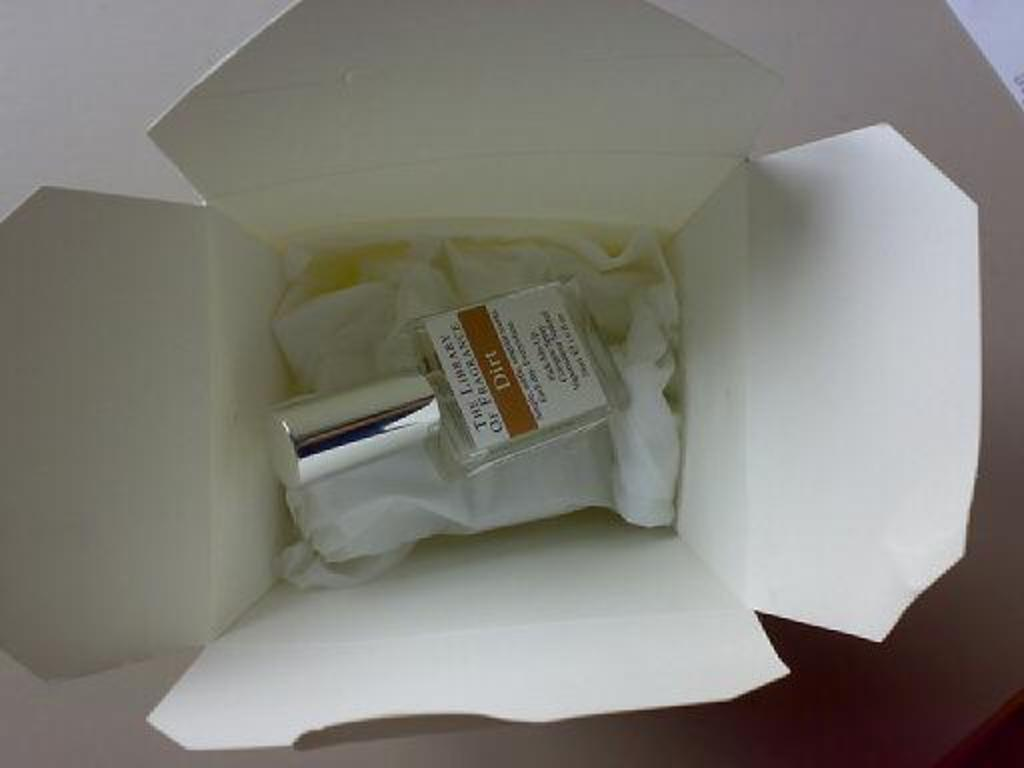What is in the picture that has a label on it? There is a bottle with a label in the picture. What can be found on the label? There is writing on the label. What type of items are in the box? There are white color clothes in a box. Where is the box located? The box is on a surface. Can you tell me how many basketballs are in the box? There are no basketballs present in the image; the box contains white color clothes. What type of cart is used to transport the box in the image? There is no cart present in the image; the box is simply on a surface. 